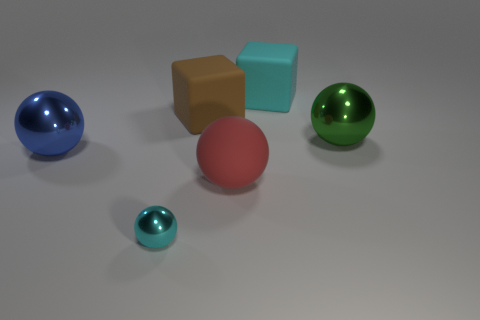Are there any other things that are the same size as the cyan sphere?
Offer a very short reply. No. There is a tiny metallic object; is its shape the same as the large metal object on the left side of the red rubber thing?
Offer a terse response. Yes. The large shiny thing that is left of the matte thing that is behind the matte block to the left of the matte ball is what color?
Your answer should be compact. Blue. Are there any matte things in front of the large blue sphere?
Give a very brief answer. Yes. What is the size of the block that is the same color as the tiny metallic ball?
Your answer should be compact. Large. Are there any big blue objects that have the same material as the small ball?
Your answer should be very brief. Yes. What is the color of the big matte ball?
Offer a terse response. Red. There is a cyan object that is left of the brown thing; is its shape the same as the green thing?
Offer a terse response. Yes. The metal object behind the large metal thing that is to the left of the big thing that is in front of the big blue ball is what shape?
Make the answer very short. Sphere. There is a block to the left of the cyan matte block; what is its material?
Ensure brevity in your answer.  Rubber. 